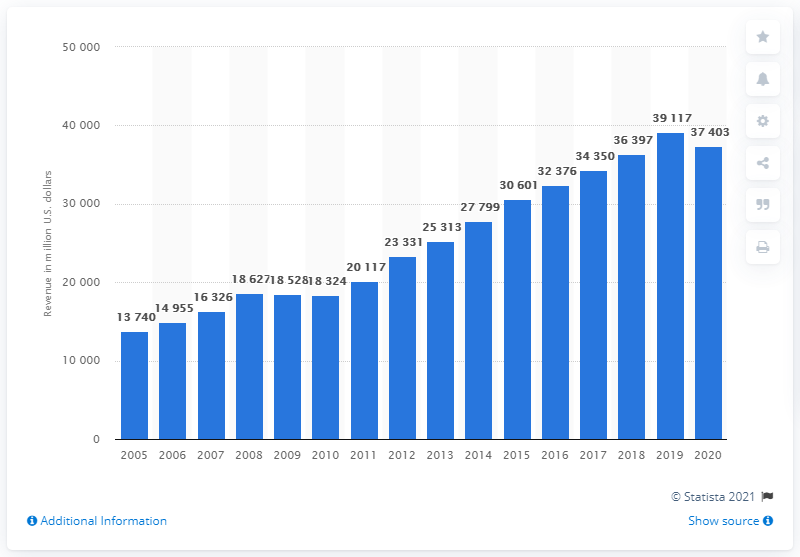Point out several critical features in this image. In 2020, Nike's global revenue was approximately 37,403 million dollars. 